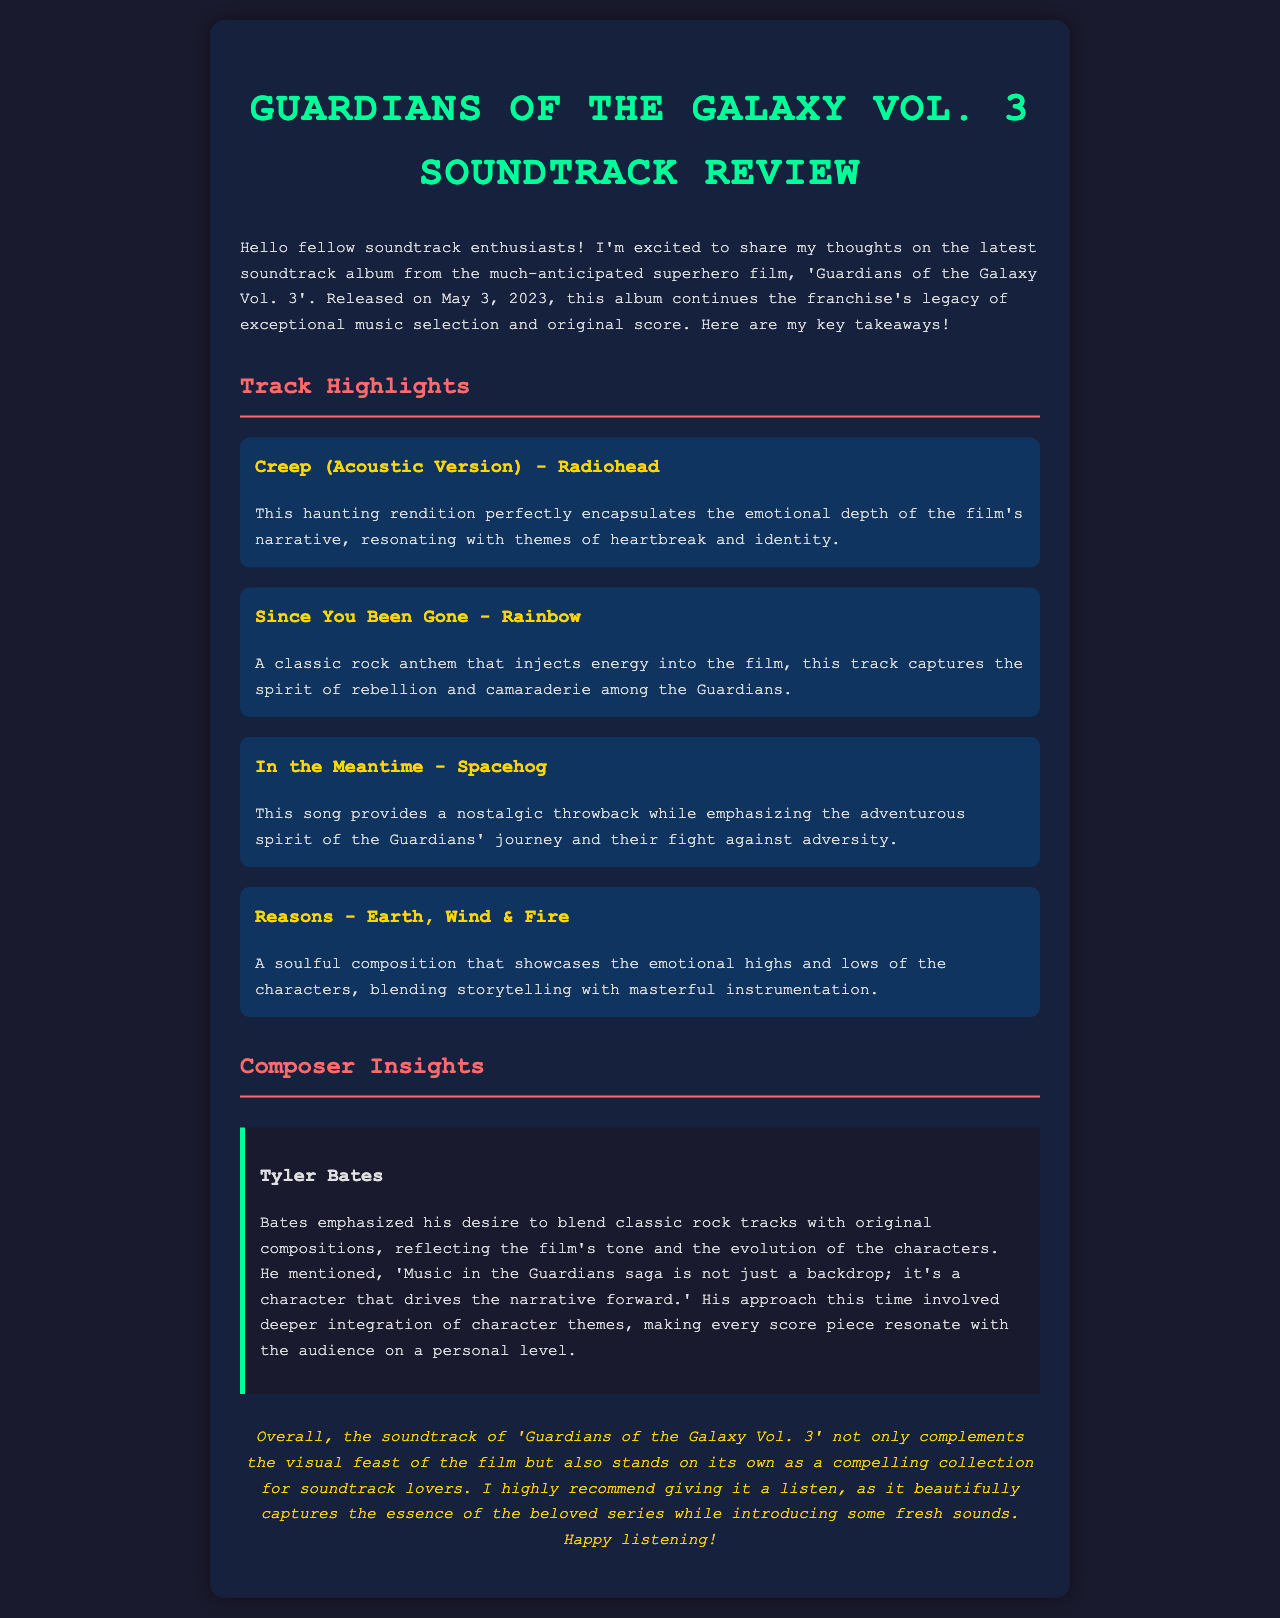What is the title of the soundtrack album? The title of the soundtrack album is presented in the header of the document.
Answer: Guardians of the Galaxy Vol. 3 Who is the composer of the soundtrack? The composer's name is mentioned in the Composer Insights section.
Answer: Tyler Bates What date was the soundtrack released? The release date is stated early in the document.
Answer: May 3, 2023 Name one track that emphasizes themes of heartbreak and identity. The track that encapsulates these themes is highlighted in the Track Highlights section.
Answer: Creep (Acoustic Version) - Radiohead What genre of music does 'Reasons' by Earth, Wind & Fire showcase? The genre is indicated in the description of the track.
Answer: Soulful What did Tyler Bates say music in the Guardians saga is? Bates' perspective on the role of music in the narrative is quoted in the Composer Insights.
Answer: A character How does the document describe the energy of 'Since You Been Gone'? The energy of the track is characterized in its description.
Answer: Classic rock anthem What is the emotional significance of 'In the Meantime'? The emotional significance is summarized in the Track Highlights section.
Answer: Nostalgic throwback What is the conclusion about the soundtrack's value? The conclusion summarizes the author's opinion on the soundtrack's overall impact.
Answer: Compelling collection for soundtrack lovers 